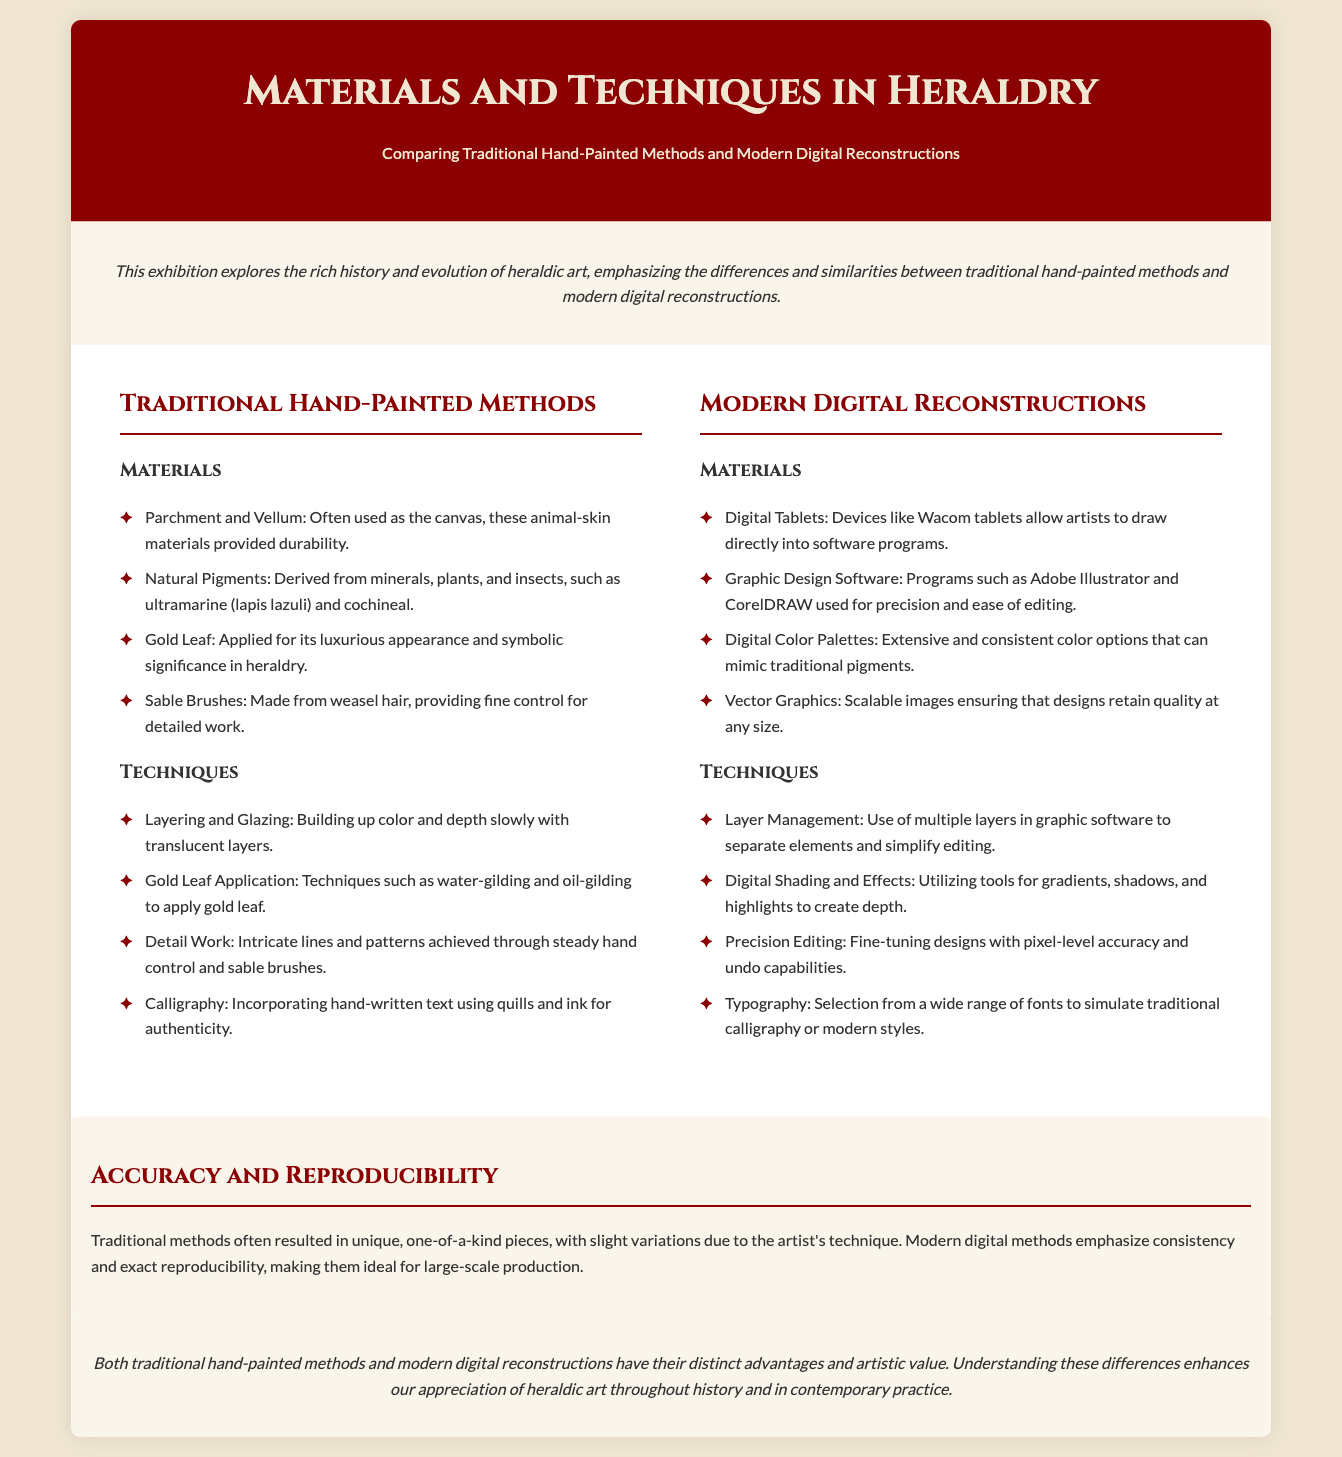what are the traditional materials used in heraldry? The traditional materials mentioned in the document are Parchment and Vellum, Natural Pigments, Gold Leaf, and Sable Brushes.
Answer: Parchment and Vellum, Natural Pigments, Gold Leaf, Sable Brushes what is a modern digital material used in heraldry? The modern digital materials mentioned include Digital Tablets, Graphic Design Software, Digital Color Palettes, and Vector Graphics.
Answer: Digital Tablets how is gold leaf applied in traditional methods? The document lists techniques such as water-gilding and oil-gilding for applying gold leaf in traditional methods.
Answer: Water-gilding and oil-gilding what is the benefit of using digital graphic design software? The document states that graphic design software offers precision and ease of editing for modern digital reconstructions.
Answer: Precision and ease of editing what technique is used for layering in digital methods? The document refers to the use of multiple layers in graphic software as a technique for managing and separating elements.
Answer: Layer Management which traditional technique involves adding shading? Traditional techniques do not specifically mention shading, but detail work emphasizes intricate lines, thus shading is associated more with modern methods.
Answer: N/A how do traditional and modern methods differ in terms of reproducibility? The document mentions that traditional methods result in unique pieces, while modern methods emphasize consistency and exact reproducibility.
Answer: Unique vs. Consistency what are the materials used in traditional methods focused on? The focus of traditional methods is on materials such as Parchment and Vellum, Natural Pigments, Gold Leaf, and Sable Brushes.
Answer: Durability and natural sources how do typography techniques differ between traditional and modern methods? Typography techniques in modern methods utilize a wide range of fonts, whereas traditional methods involve hand-written calligraphy.
Answer: Wide range of fonts vs. hand-written calligraphy 